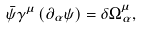<formula> <loc_0><loc_0><loc_500><loc_500>\bar { \psi } \gamma ^ { \mu } \left ( \partial _ { \alpha } \psi \right ) = \delta \Omega _ { \alpha } ^ { \mu } ,</formula> 